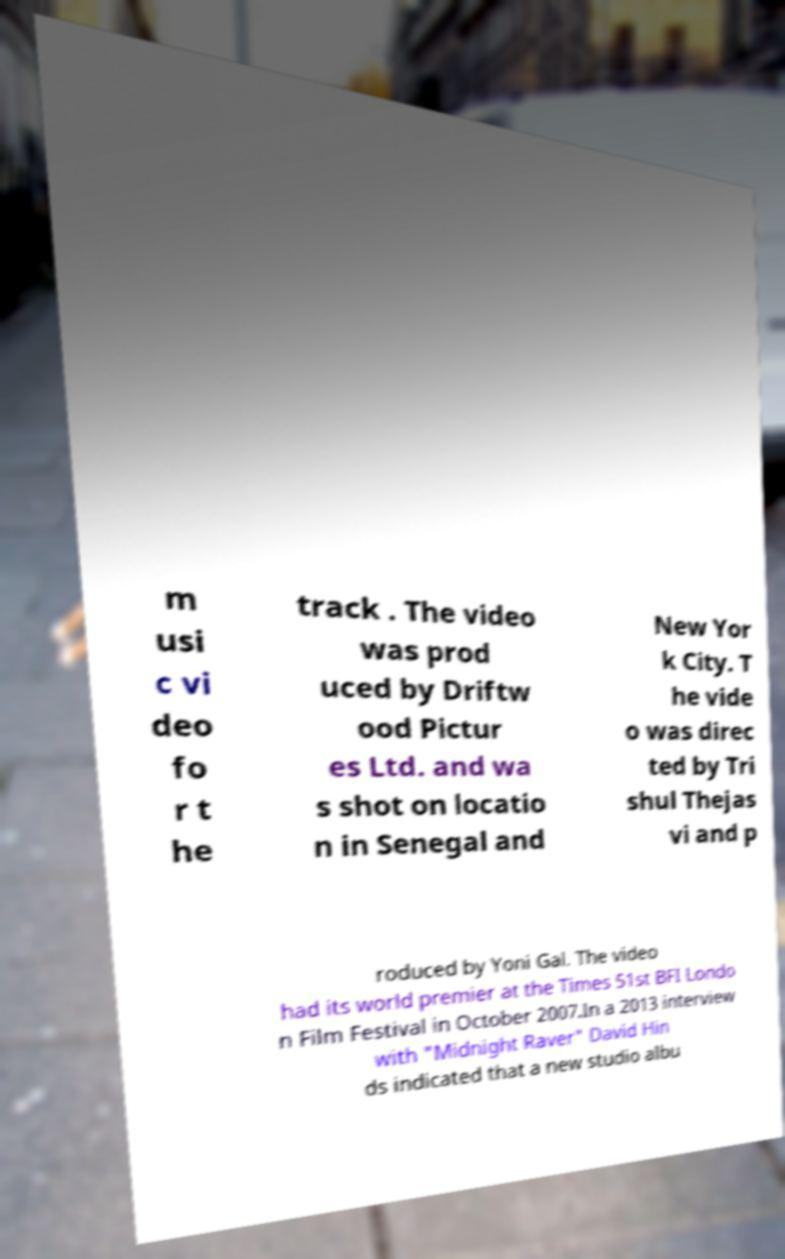Could you extract and type out the text from this image? m usi c vi deo fo r t he track . The video was prod uced by Driftw ood Pictur es Ltd. and wa s shot on locatio n in Senegal and New Yor k City. T he vide o was direc ted by Tri shul Thejas vi and p roduced by Yoni Gal. The video had its world premier at the Times 51st BFI Londo n Film Festival in October 2007.In a 2013 interview with "Midnight Raver" David Hin ds indicated that a new studio albu 